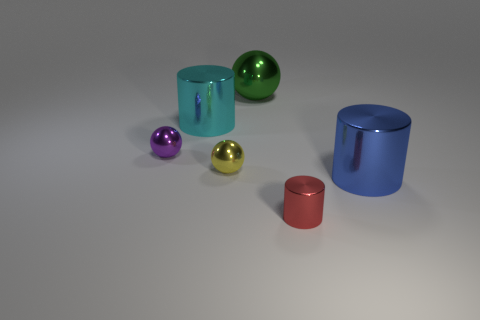Add 4 purple metallic spheres. How many objects exist? 10 Add 3 cyan things. How many cyan things are left? 4 Add 2 shiny objects. How many shiny objects exist? 8 Subtract 1 red cylinders. How many objects are left? 5 Subtract all metallic spheres. Subtract all small red matte cylinders. How many objects are left? 3 